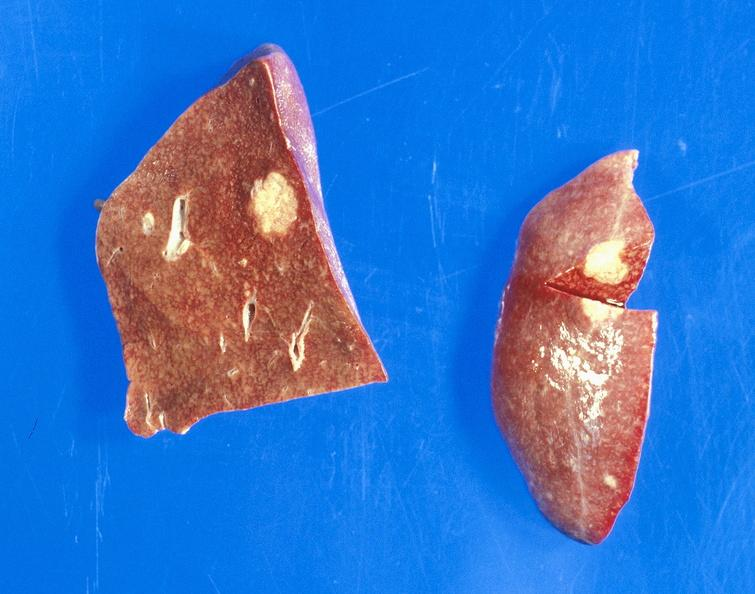s mesentery present?
Answer the question using a single word or phrase. No 